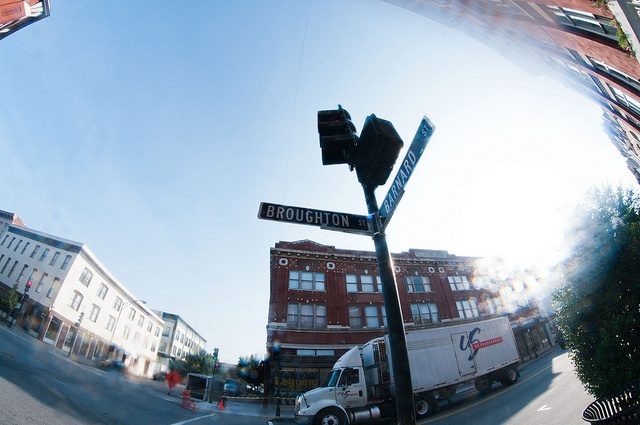Describe the objects in this image and their specific colors. I can see truck in salmon, black, and gray tones, traffic light in salmon, black, lightgray, navy, and lightblue tones, truck in salmon, black, blue, and darkblue tones, and traffic light in salmon, gray, blue, and teal tones in this image. 